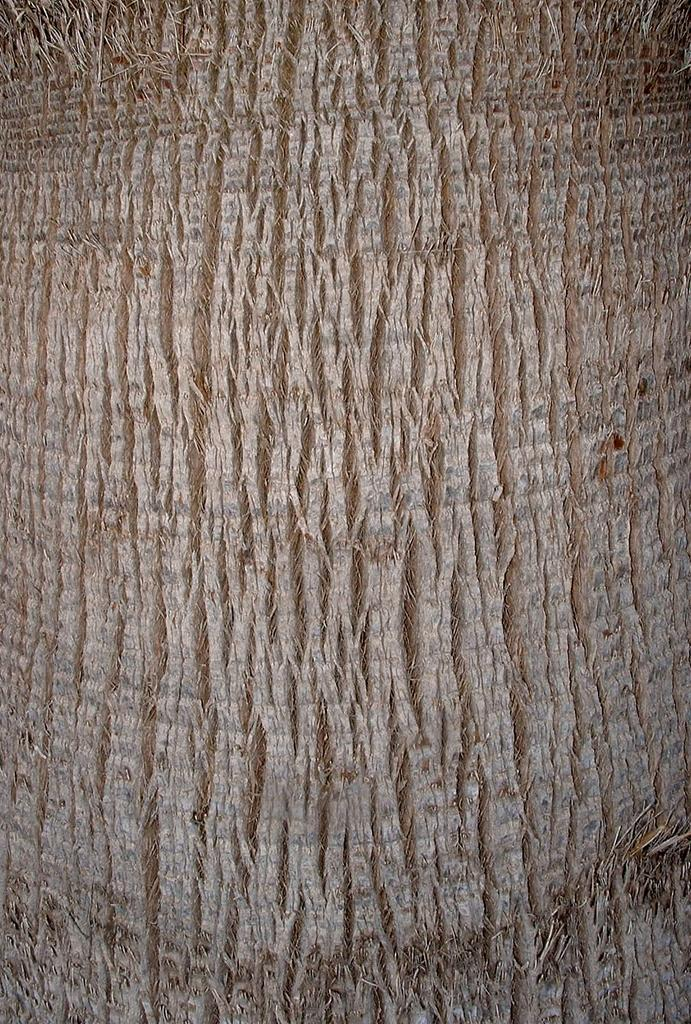What type of natural element is present in the image? There is a tree in the image. What type of cave can be seen in the background of the image? There is no cave present in the image; it only features a tree. How many fields are visible in the image? There are no fields visible in the image; it only features a tree. 